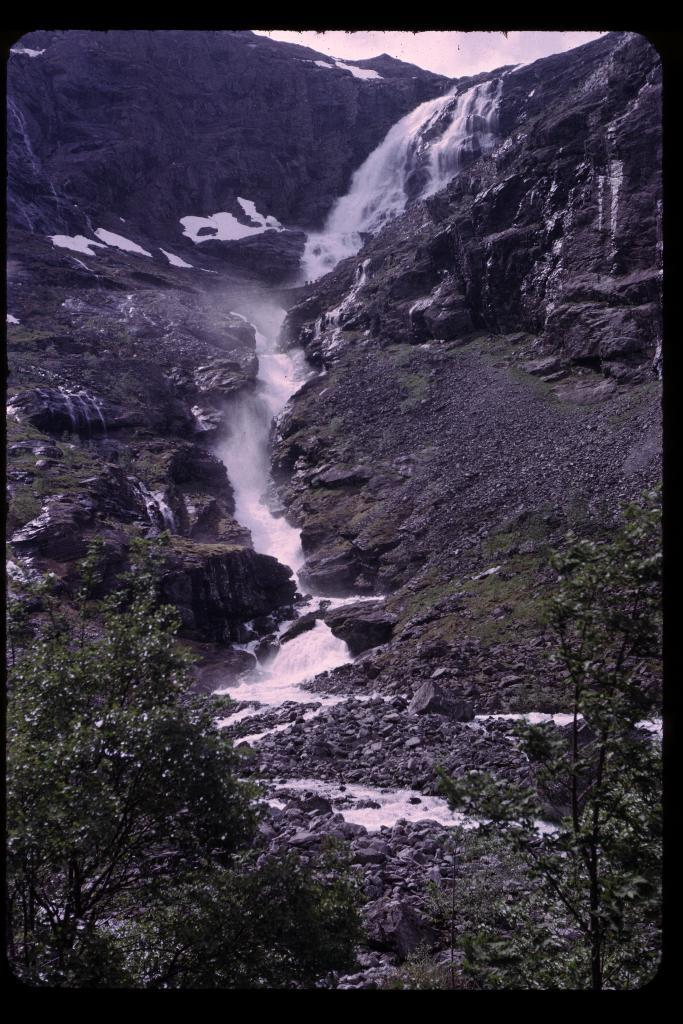What is the main feature in the middle of the image? There is a waterfall in the middle of the image. What can be seen at the base of the waterfall? There are plants at the bottom of the waterfall. How is the water moving in the image? Water is flowing in a line in the middle of the image. What type of surface is visible on the ground in the image? There are stones on the ground in the image. What type of canvas is used to create the waterfall in the image? The image is a photograph, not a painting, so there is no canvas used to create the waterfall. 